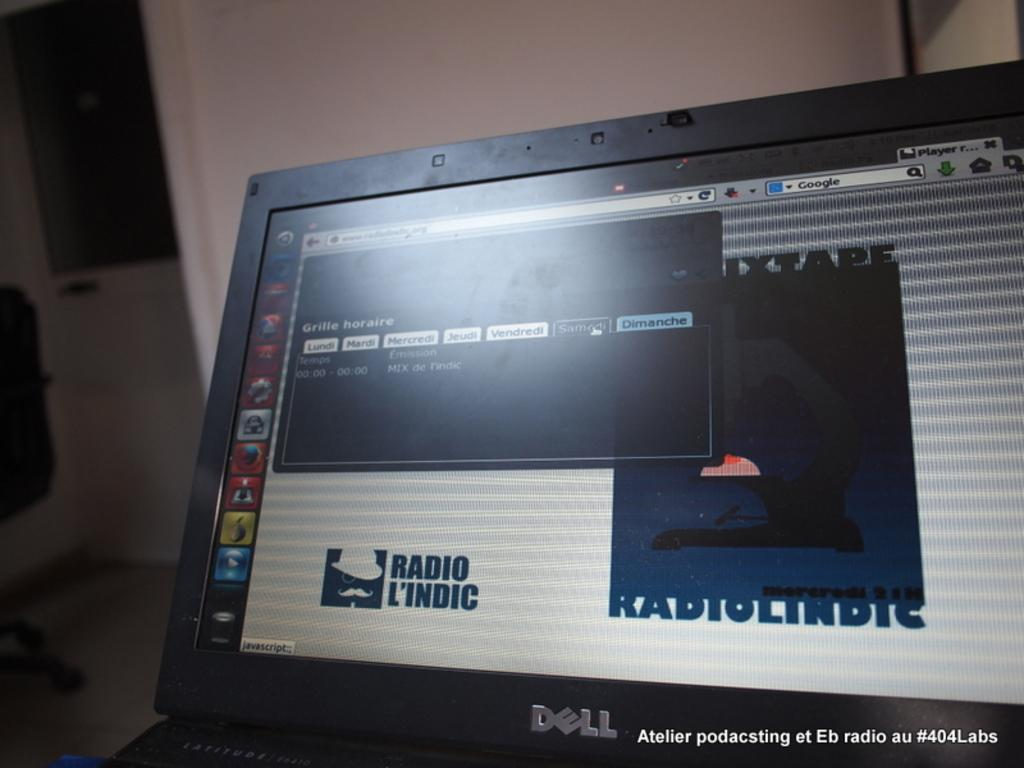Provide a one-sentence caption for the provided image. A dell laptop screen displaying Radio L'indic logo on it. 